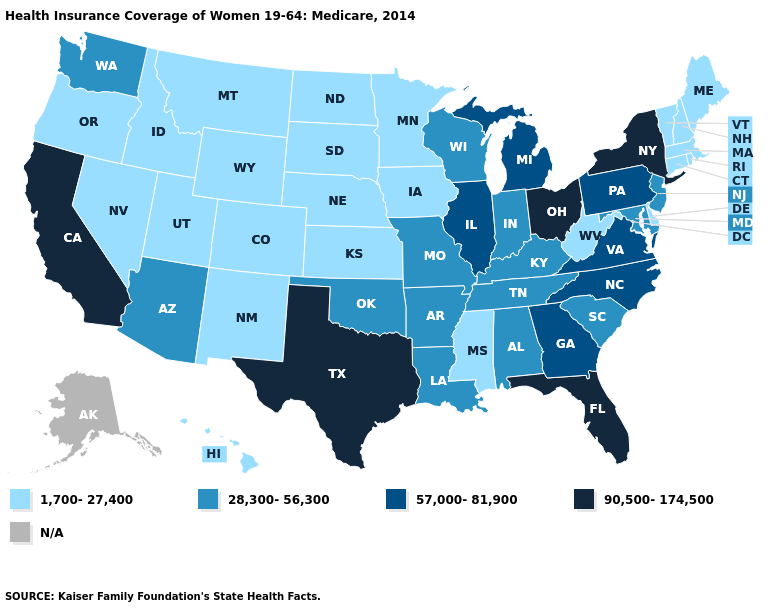Name the states that have a value in the range 57,000-81,900?
Short answer required. Georgia, Illinois, Michigan, North Carolina, Pennsylvania, Virginia. What is the value of Missouri?
Give a very brief answer. 28,300-56,300. What is the value of Louisiana?
Be succinct. 28,300-56,300. What is the highest value in the USA?
Answer briefly. 90,500-174,500. What is the highest value in the West ?
Answer briefly. 90,500-174,500. What is the highest value in the West ?
Write a very short answer. 90,500-174,500. How many symbols are there in the legend?
Concise answer only. 5. What is the value of South Carolina?
Short answer required. 28,300-56,300. What is the highest value in the MidWest ?
Be succinct. 90,500-174,500. Name the states that have a value in the range 90,500-174,500?
Be succinct. California, Florida, New York, Ohio, Texas. What is the value of Delaware?
Write a very short answer. 1,700-27,400. Name the states that have a value in the range 1,700-27,400?
Concise answer only. Colorado, Connecticut, Delaware, Hawaii, Idaho, Iowa, Kansas, Maine, Massachusetts, Minnesota, Mississippi, Montana, Nebraska, Nevada, New Hampshire, New Mexico, North Dakota, Oregon, Rhode Island, South Dakota, Utah, Vermont, West Virginia, Wyoming. What is the value of North Dakota?
Short answer required. 1,700-27,400. Is the legend a continuous bar?
Write a very short answer. No. Among the states that border Idaho , does Nevada have the lowest value?
Answer briefly. Yes. 